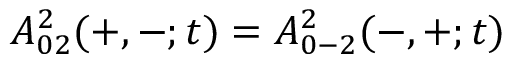<formula> <loc_0><loc_0><loc_500><loc_500>A _ { 0 2 } ^ { 2 } ( + , - ; t ) = A _ { 0 - 2 } ^ { 2 } ( - , + ; t )</formula> 